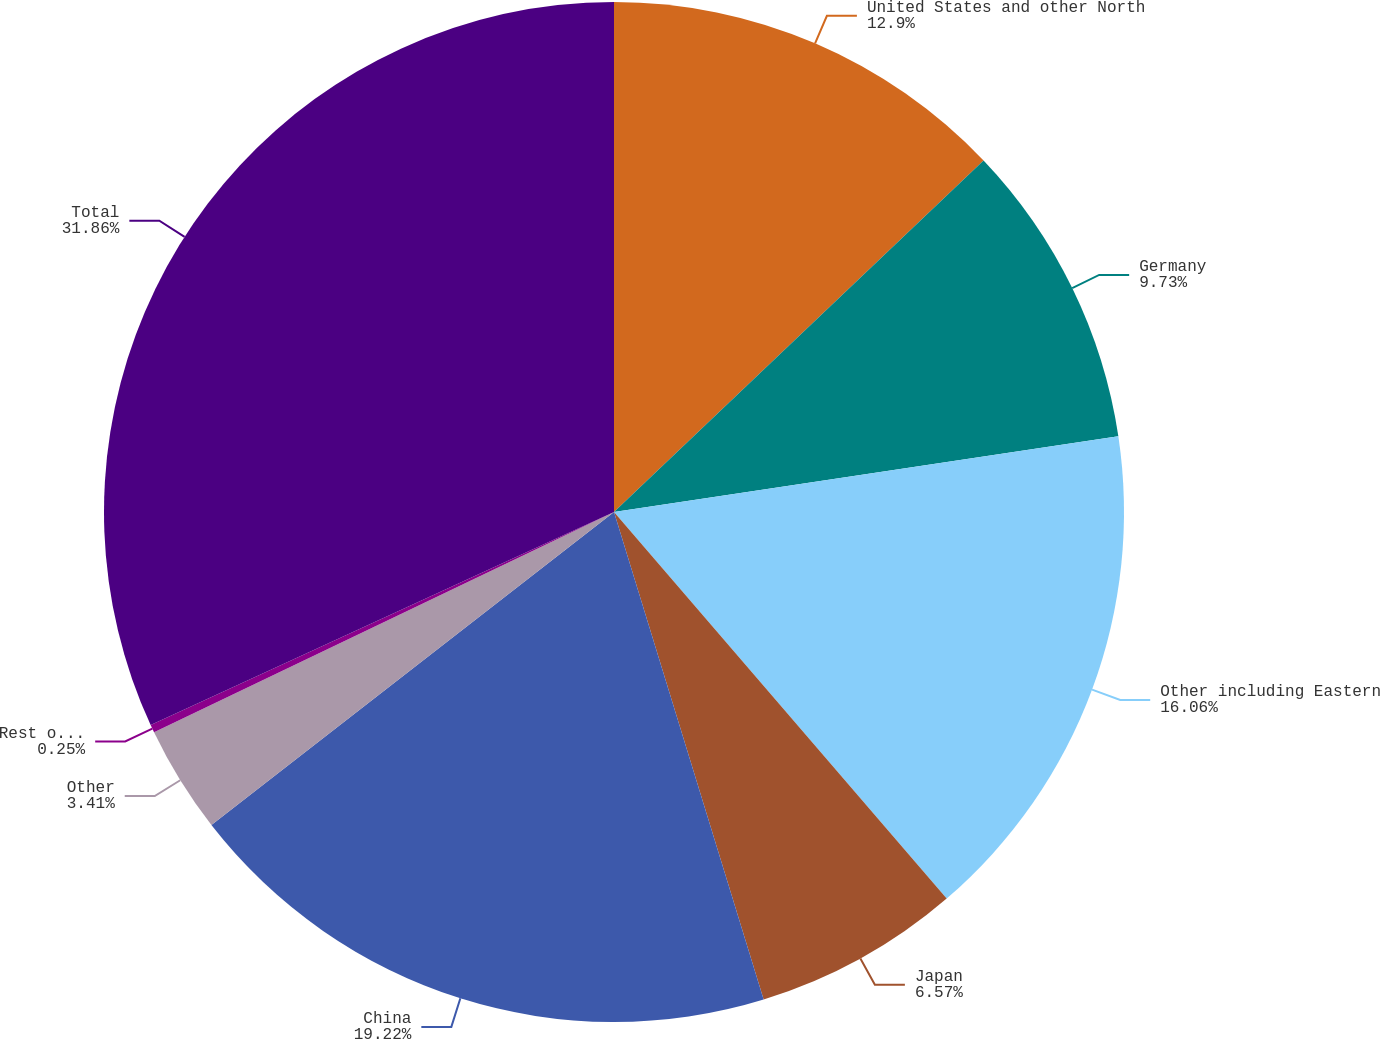Convert chart. <chart><loc_0><loc_0><loc_500><loc_500><pie_chart><fcel>United States and other North<fcel>Germany<fcel>Other including Eastern<fcel>Japan<fcel>China<fcel>Other<fcel>Rest of World<fcel>Total<nl><fcel>12.9%<fcel>9.73%<fcel>16.06%<fcel>6.57%<fcel>19.22%<fcel>3.41%<fcel>0.25%<fcel>31.86%<nl></chart> 